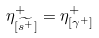Convert formula to latex. <formula><loc_0><loc_0><loc_500><loc_500>\eta ^ { + } _ { [ \widetilde { { s } ^ { + } } ] } = \eta ^ { + } _ { [ \gamma ^ { + } ] }</formula> 